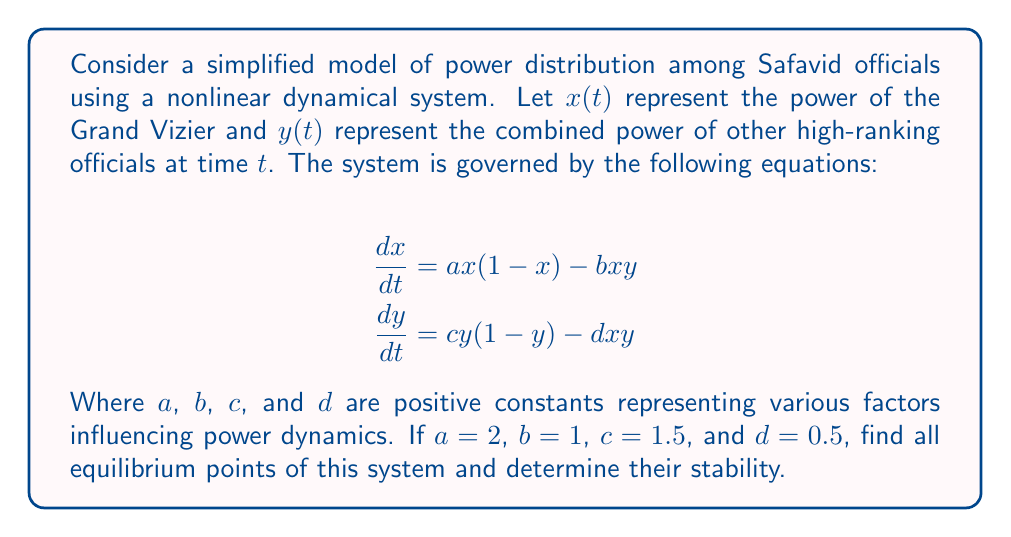Show me your answer to this math problem. To solve this problem, we'll follow these steps:

1) Find the equilibrium points by setting both equations to zero:
   $$\frac{dx}{dt} = 2x(1-x) - xy = 0$$
   $$\frac{dy}{dt} = 1.5y(1-y) - 0.5xy = 0$$

2) Solve these equations:
   From the first equation:
   $x(2-2x-y) = 0$, so either $x=0$ or $2-2x-y=0$
   From the second equation:
   $y(1.5-1.5y-0.5x) = 0$, so either $y=0$ or $1.5-1.5y-0.5x=0$

3) Consider all possible combinations:
   a) $x=0$ and $y=0$: This is the trivial equilibrium point (0,0)
   b) $x=0$ and $1.5-1.5y-0.5x=0$: This gives $y=1$, so (0,1) is an equilibrium point
   c) $2-2x-y=0$ and $y=0$: This gives $x=1$, so (1,0) is an equilibrium point
   d) $2-2x-y=0$ and $1.5-1.5y-0.5x=0$: Solving these simultaneously:
      $2-2x-y=0$ and $3-3y-x=0$
      Subtracting: $-x+2y=1$, or $y=\frac{1+x}{2}$
      Substituting into $2-2x-y=0$: $2-2x-\frac{1+x}{2}=0$
      Solving: $x=\frac{2}{3}$, and consequently $y=\frac{5}{6}$
      So $(\frac{2}{3},\frac{5}{6})$ is an equilibrium point

4) To determine stability, we need to find the Jacobian matrix and evaluate it at each equilibrium point:
   $$J = \begin{bmatrix} 
   2-4x-y & -x \\
   -0.5y & 1.5-3y-0.5x
   \end{bmatrix}$$

5) Evaluate stability for each point:
   a) At (0,0): $J = \begin{bmatrix} 2 & 0 \\ 0 & 1.5 \end{bmatrix}$
      Both eigenvalues are positive, so this is an unstable node.
   b) At (0,1): $J = \begin{bmatrix} 1 & 0 \\ -0.5 & -1.5 \end{bmatrix}$
      Eigenvalues are 1 and -1.5, so this is a saddle point (unstable).
   c) At (1,0): $J = \begin{bmatrix} -2 & -1 \\ 0 & 1 \end{bmatrix}$
      Eigenvalues are -2 and 1, so this is a saddle point (unstable).
   d) At $(\frac{2}{3},\frac{5}{6})$: 
      $J = \begin{bmatrix} -\frac{2}{3} & -\frac{2}{3} \\ -\frac{5}{12} & -\frac{5}{12} \end{bmatrix}$
      The eigenvalues are $-\frac{13}{12}$ and $\frac{1}{12}$, so this is a saddle point (unstable).
Answer: Equilibrium points: (0,0), (0,1), (1,0), $(\frac{2}{3},\frac{5}{6})$. All are unstable. 